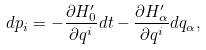<formula> <loc_0><loc_0><loc_500><loc_500>d p _ { i } = - \frac { \partial H _ { 0 } ^ { \prime } } { \partial q ^ { i } } d t - \frac { \partial H _ { \alpha } ^ { \prime } } { \partial q ^ { i } } d q _ { \alpha } ,</formula> 